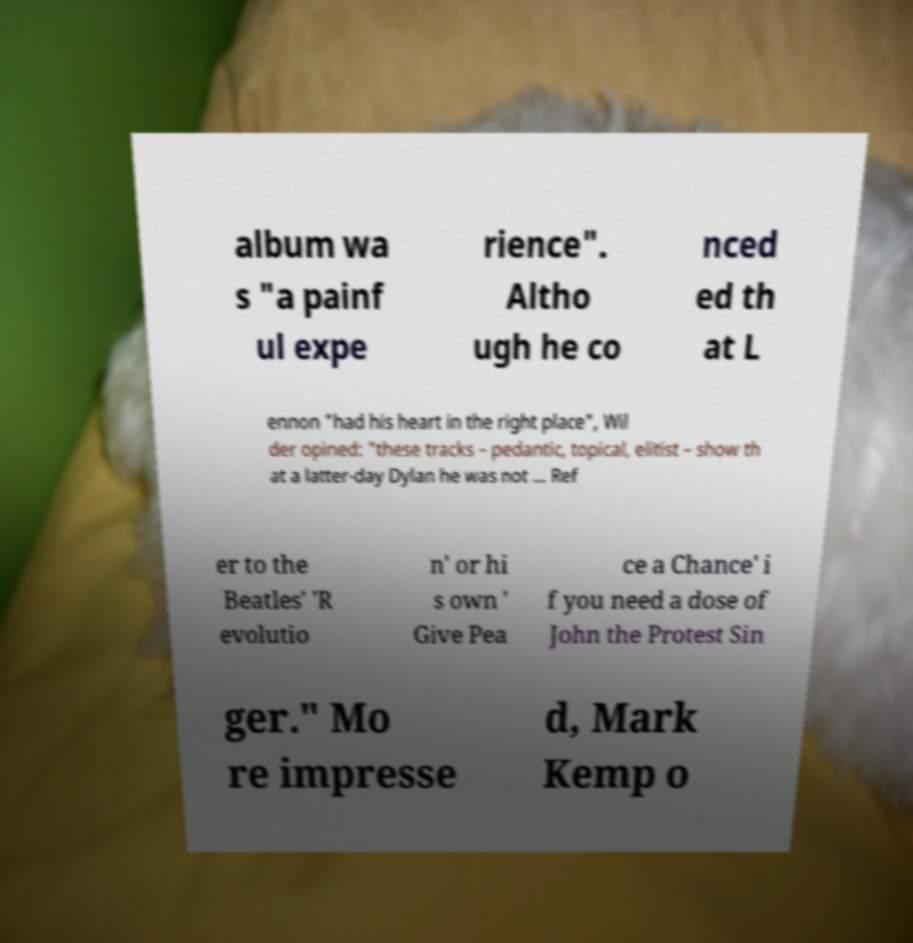Could you assist in decoding the text presented in this image and type it out clearly? album wa s "a painf ul expe rience". Altho ugh he co nced ed th at L ennon "had his heart in the right place", Wil der opined: "these tracks – pedantic, topical, elitist – show th at a latter-day Dylan he was not ... Ref er to the Beatles' 'R evolutio n' or hi s own ' Give Pea ce a Chance' i f you need a dose of John the Protest Sin ger." Mo re impresse d, Mark Kemp o 